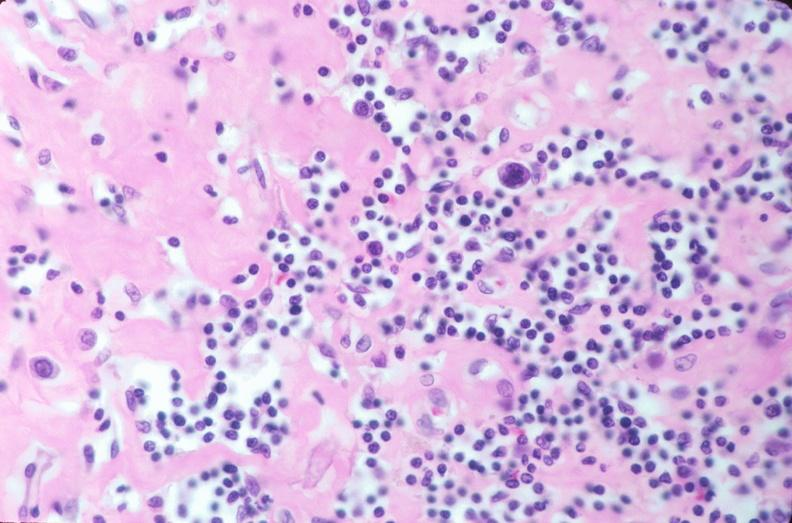does hypertension show lymph nodes, nodular sclerosing hodgkins disease?
Answer the question using a single word or phrase. No 